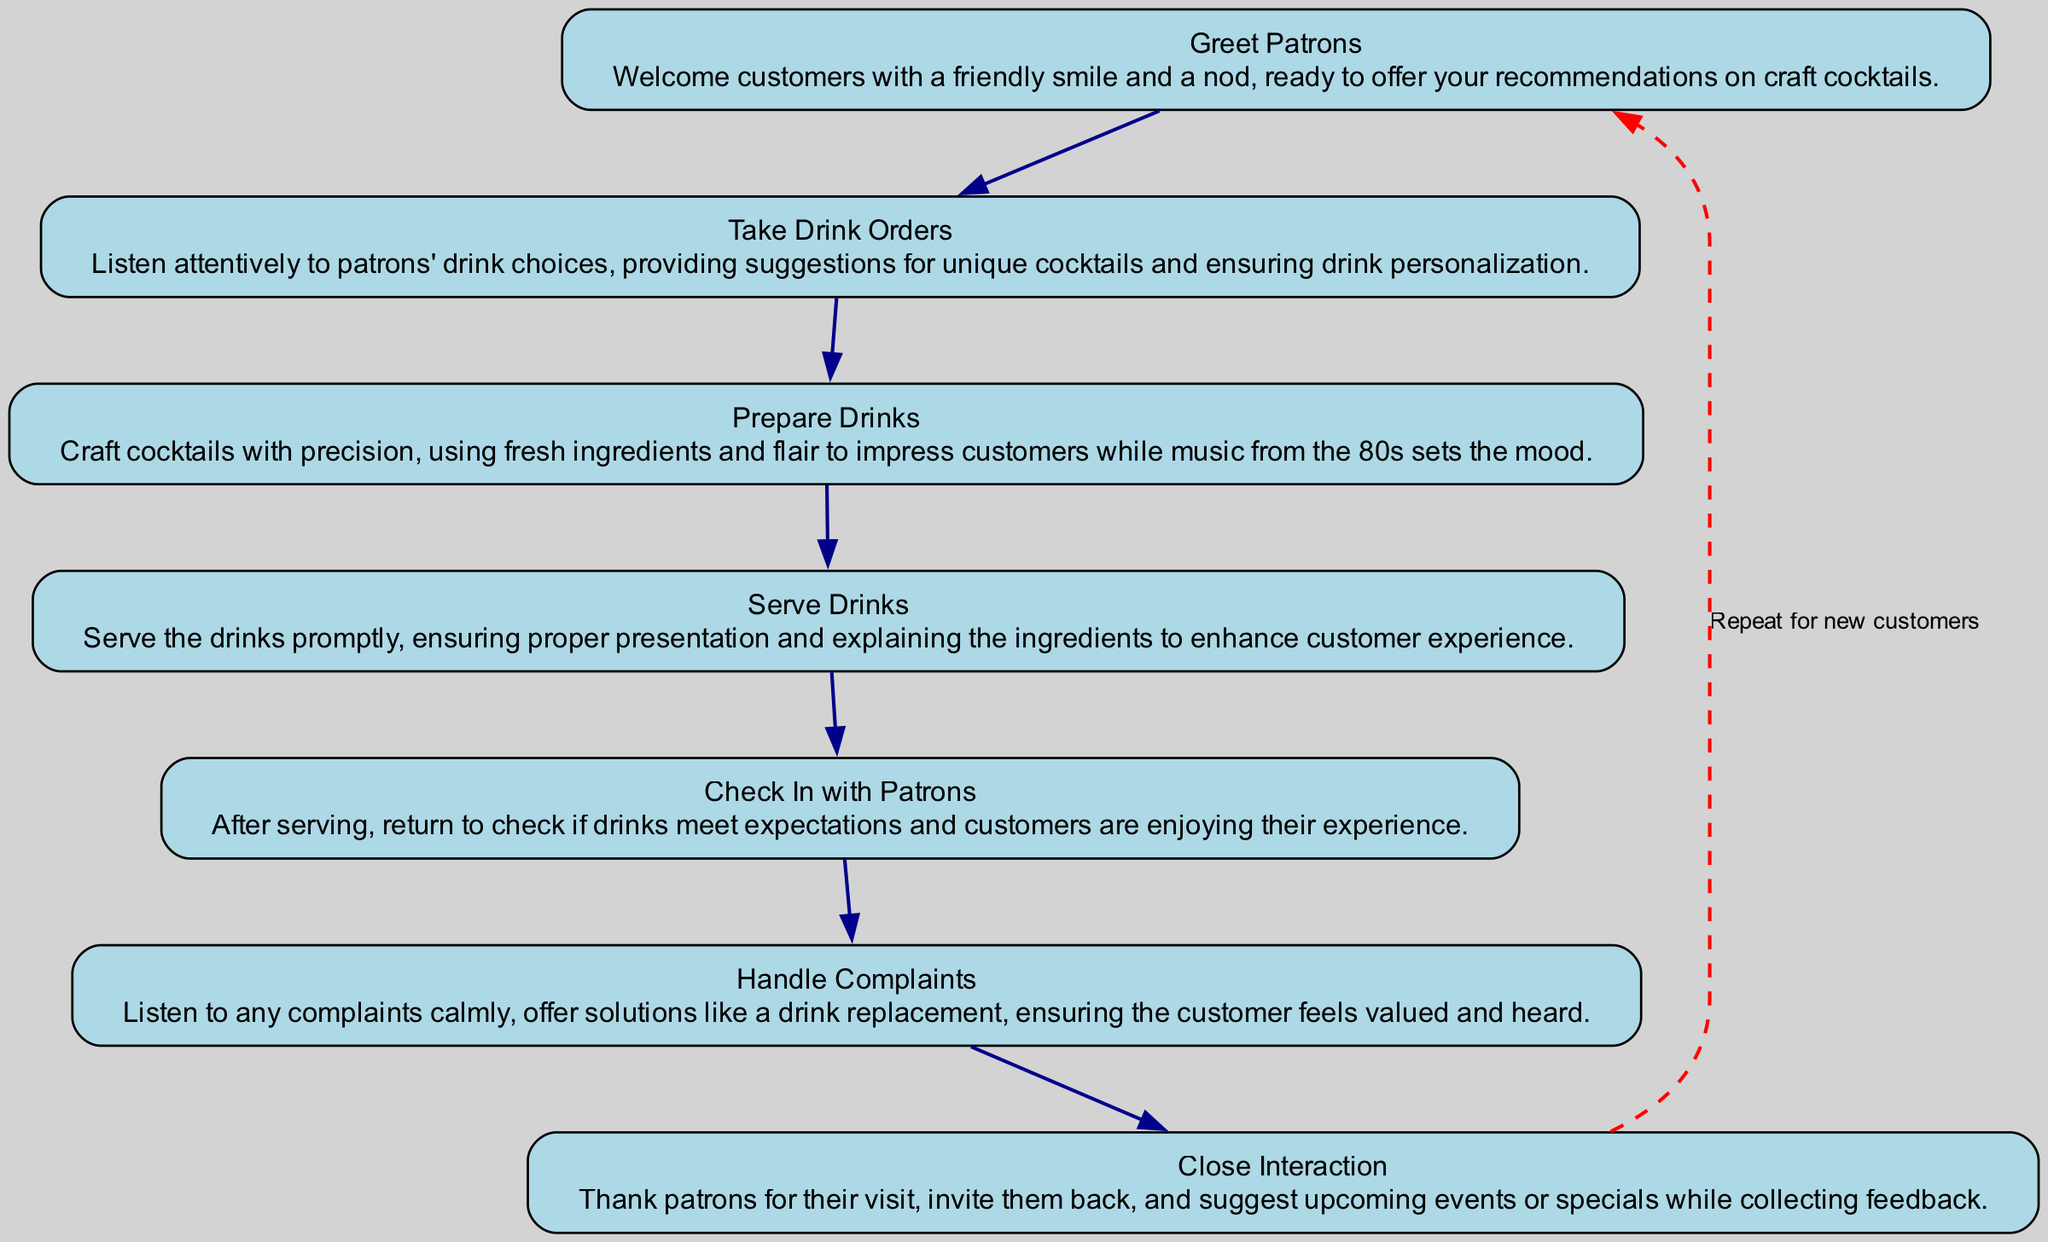What is the first step in the customer service workflow? The first node in the workflow is "Greet Patrons," which initiates the process. This node is located at the top of the flow chart, indicating the starting point for customer service.
Answer: Greet Patrons How many nodes are present in the diagram? The diagram contains seven nodes, each representing a specific step in the customer service workflow. These nodes include actions like "Greet Patrons," "Take Drink Orders," and others.
Answer: Seven What follows after "Check In with Patrons"? According to the flow, after "Check In with Patrons," the next step is "Handle Complaints." This relationship is illustrated by the directed edge connecting these two nodes.
Answer: Handle Complaints What does the dashed red edge from "Close Interaction" point to? The dashed red edge from "Close Interaction" points back to "Greet Patrons," indicating a cyclic nature in which the workflow repeats for new customers after concluding an interaction.
Answer: Greet Patrons Which step involves listening to customer complaints? The step involving listening to complaints is "Handle Complaints," specifically highlighting the importance of addressing customer concerns and offering solutions to enhance their experience.
Answer: Handle Complaints What is the last step listed in the workflow before it cycles back? The last step before cycling back is "Close Interaction." This is where the bartender thanks patrons and invites them for future visits.
Answer: Close Interaction What is the fourth step in the workflow? The fourth step in the workflow is "Serve Drinks." This step comes after preparing the drinks and is vital for ensuring patrons receive their beverages promptly and presented well.
Answer: Serve Drinks How does a bartender ensure customers feel valued during complaints? A bartender ensures customers feel valued during complaints by actively listening and offering solutions, as described in the "Handle Complaints" step. This emphasizes the importance of customer satisfaction.
Answer: Offering solutions 